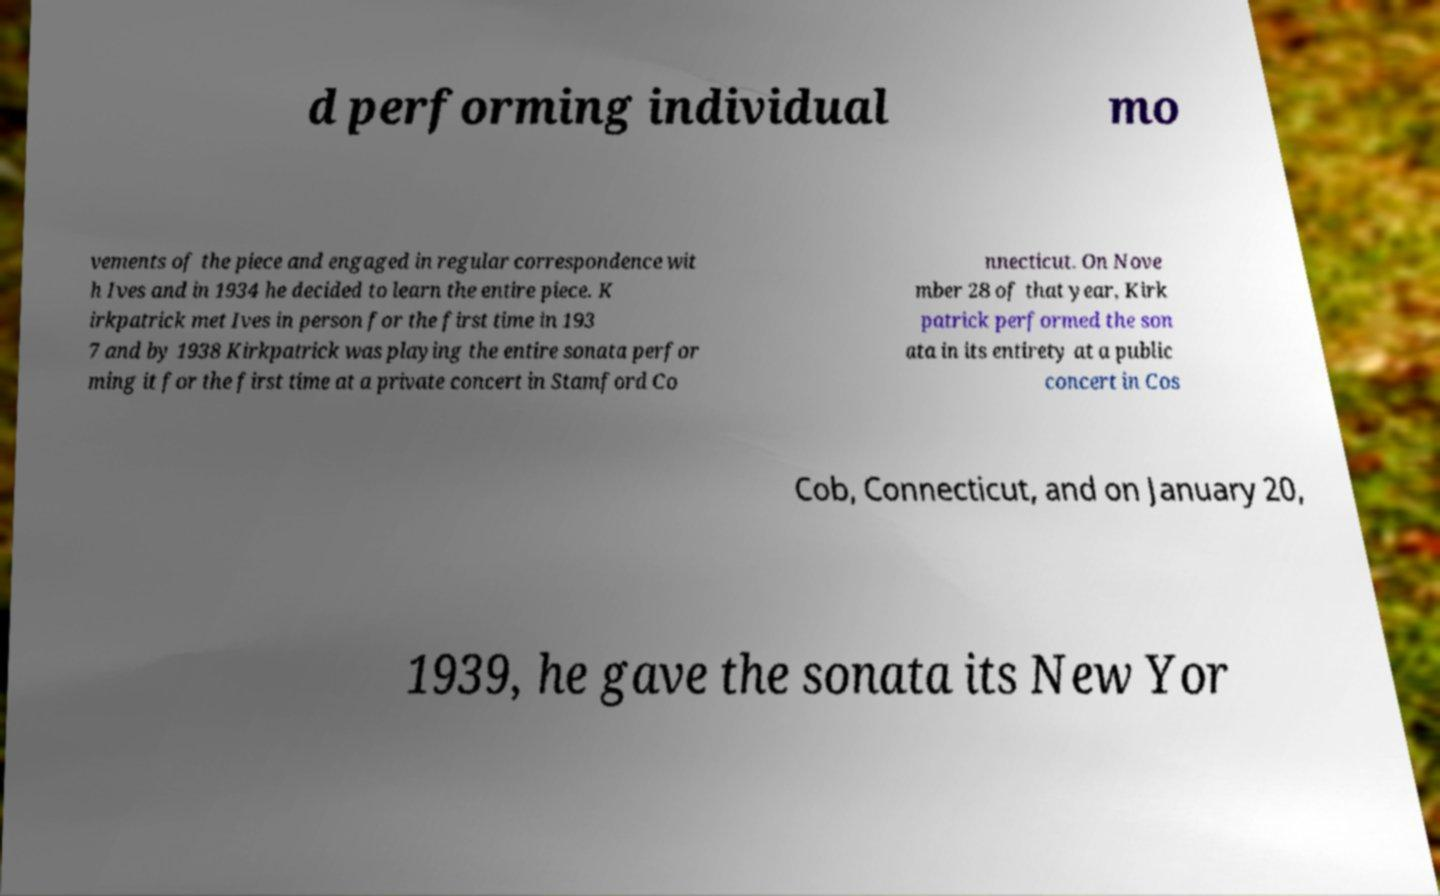Can you read and provide the text displayed in the image?This photo seems to have some interesting text. Can you extract and type it out for me? d performing individual mo vements of the piece and engaged in regular correspondence wit h Ives and in 1934 he decided to learn the entire piece. K irkpatrick met Ives in person for the first time in 193 7 and by 1938 Kirkpatrick was playing the entire sonata perfor ming it for the first time at a private concert in Stamford Co nnecticut. On Nove mber 28 of that year, Kirk patrick performed the son ata in its entirety at a public concert in Cos Cob, Connecticut, and on January 20, 1939, he gave the sonata its New Yor 